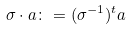Convert formula to latex. <formula><loc_0><loc_0><loc_500><loc_500>\sigma \cdot a \colon = ( \sigma ^ { - 1 } ) ^ { t } a</formula> 